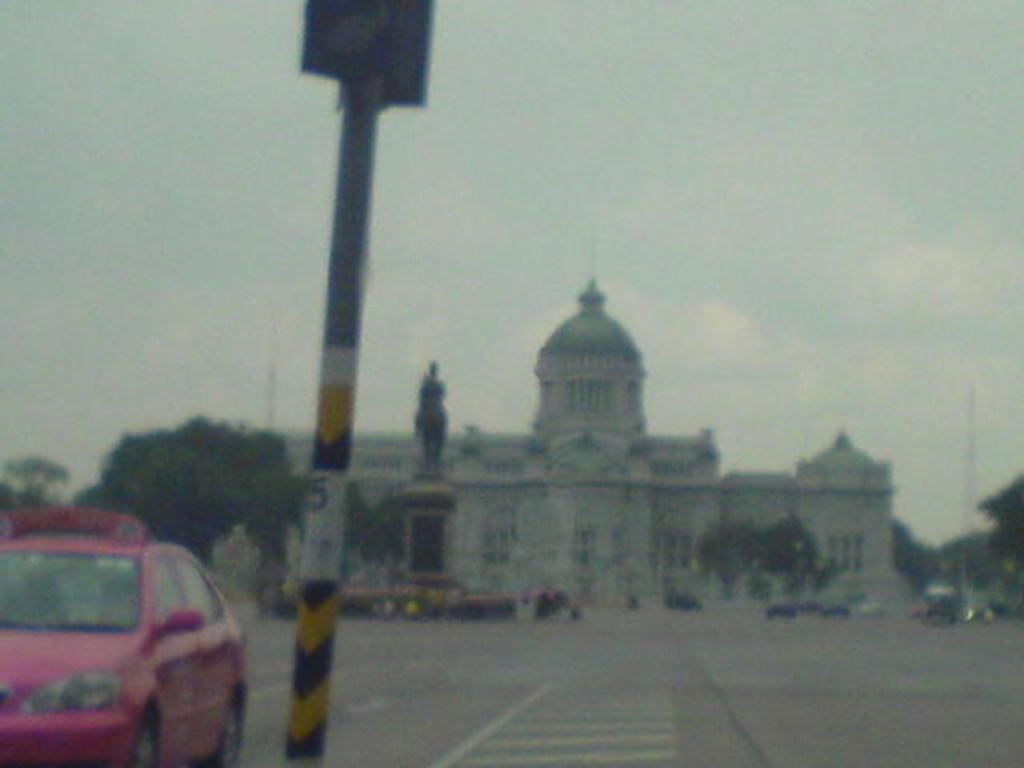Please provide a concise description of this image. In this image we can see a building. There are many trees and plants in the image. There is a sculpture in the image. There is a sky in the image. There are many vehicles on the road. There is a pole in the image. 